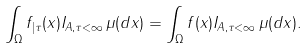<formula> <loc_0><loc_0><loc_500><loc_500>\int _ { \Omega } f _ { | \tau } ( x ) I _ { A , \tau < \infty } \, \mu ( d x ) = \int _ { \Omega } f ( x ) I _ { A , \tau < \infty } \, \mu ( d x ) .</formula> 